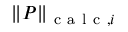<formula> <loc_0><loc_0><loc_500><loc_500>\| P \| _ { c a l c , i }</formula> 